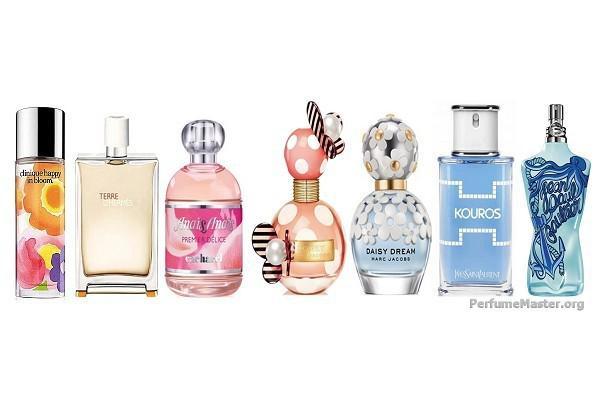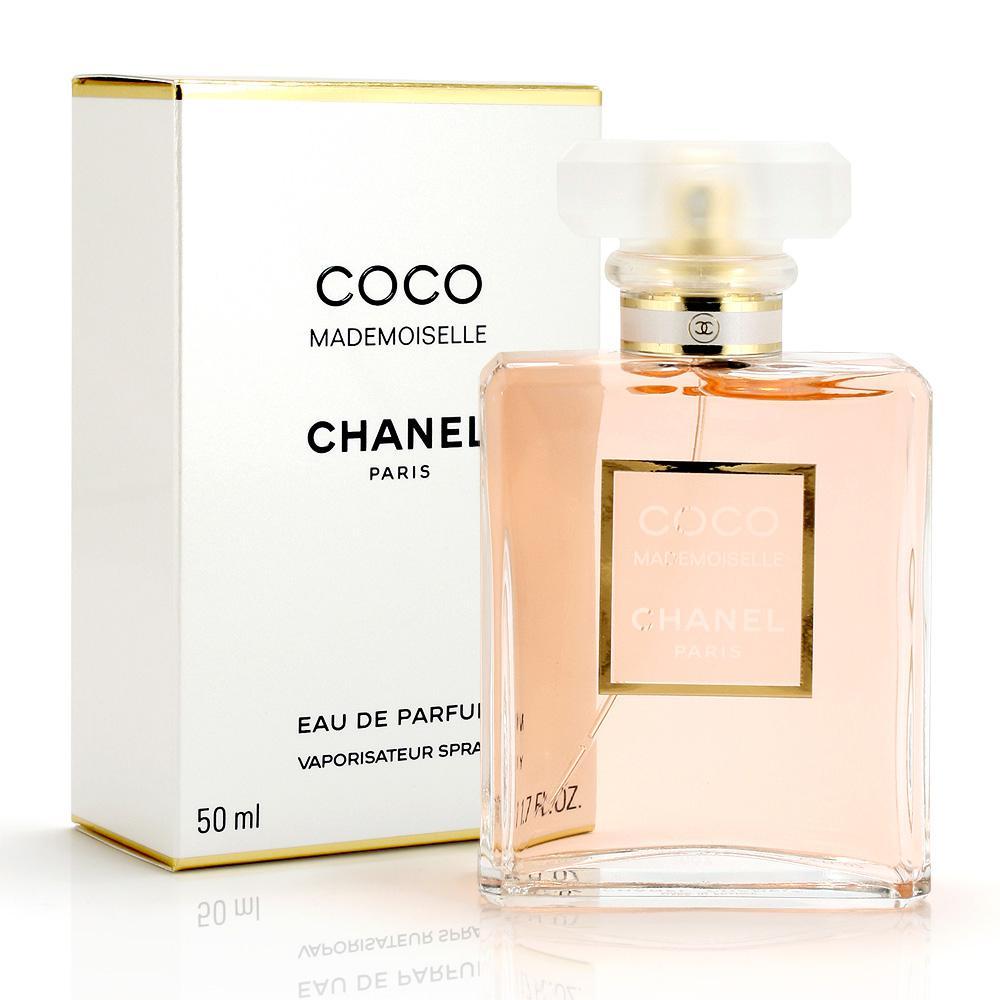The first image is the image on the left, the second image is the image on the right. Evaluate the accuracy of this statement regarding the images: "The left image features a horizontal row of at least five different fragrance bottle shapes, while the right image shows at least one bottle in front of its box.". Is it true? Answer yes or no. Yes. 